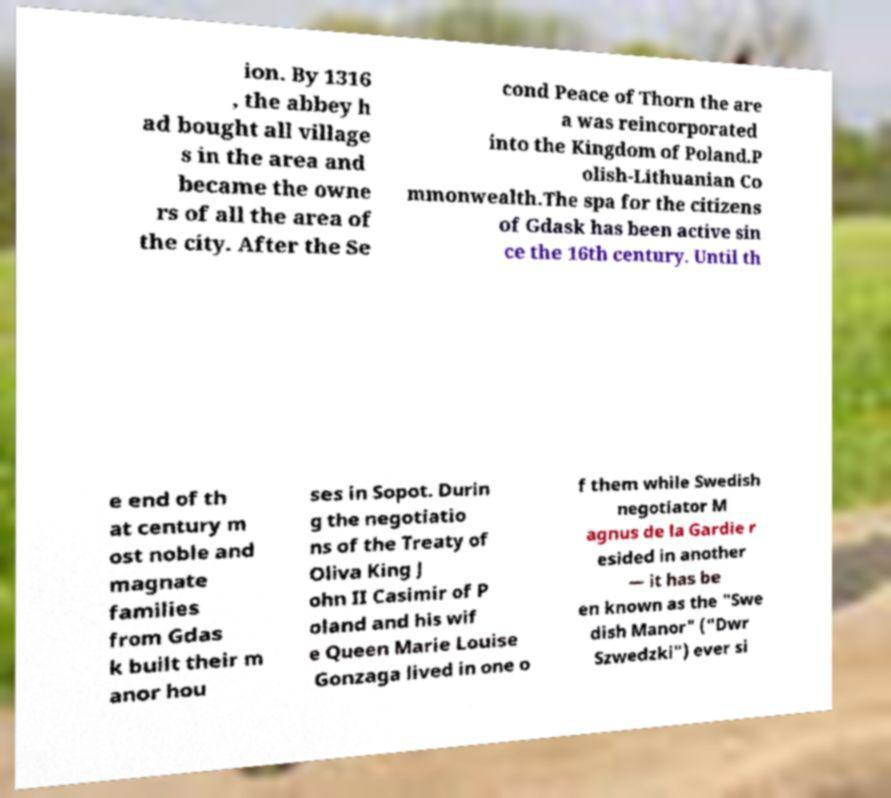For documentation purposes, I need the text within this image transcribed. Could you provide that? ion. By 1316 , the abbey h ad bought all village s in the area and became the owne rs of all the area of the city. After the Se cond Peace of Thorn the are a was reincorporated into the Kingdom of Poland.P olish-Lithuanian Co mmonwealth.The spa for the citizens of Gdask has been active sin ce the 16th century. Until th e end of th at century m ost noble and magnate families from Gdas k built their m anor hou ses in Sopot. Durin g the negotiatio ns of the Treaty of Oliva King J ohn II Casimir of P oland and his wif e Queen Marie Louise Gonzaga lived in one o f them while Swedish negotiator M agnus de la Gardie r esided in another — it has be en known as the "Swe dish Manor" ("Dwr Szwedzki") ever si 